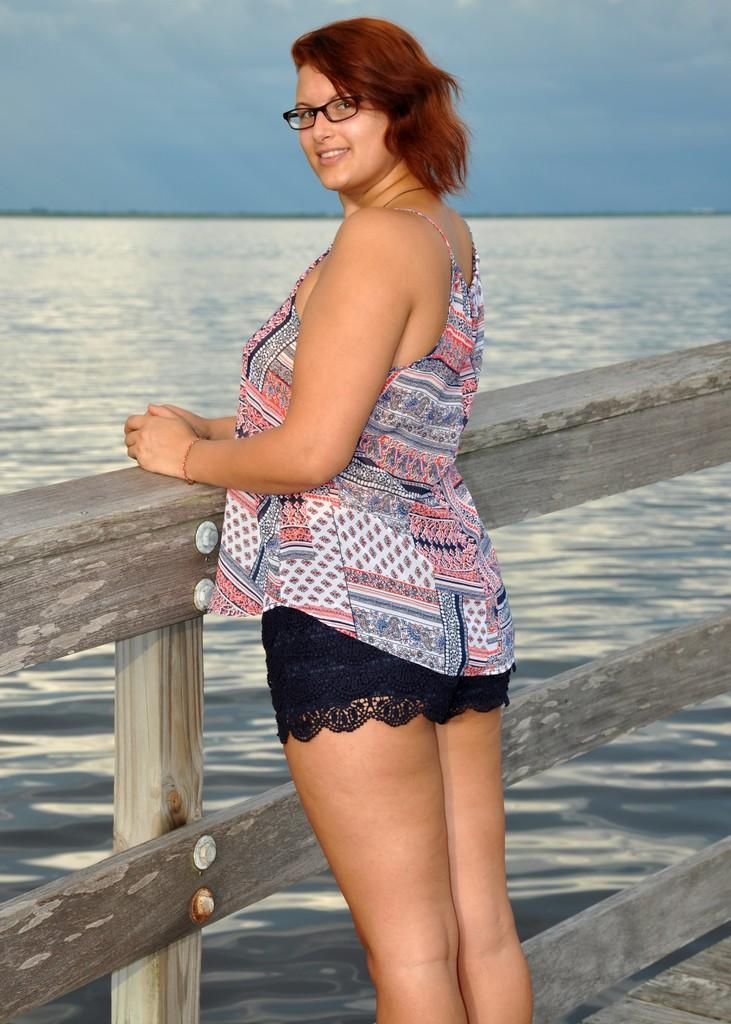In one or two sentences, can you explain what this image depicts? In this image we can see a woman standing on the walkway bridge. In the background we can see water and sky. 